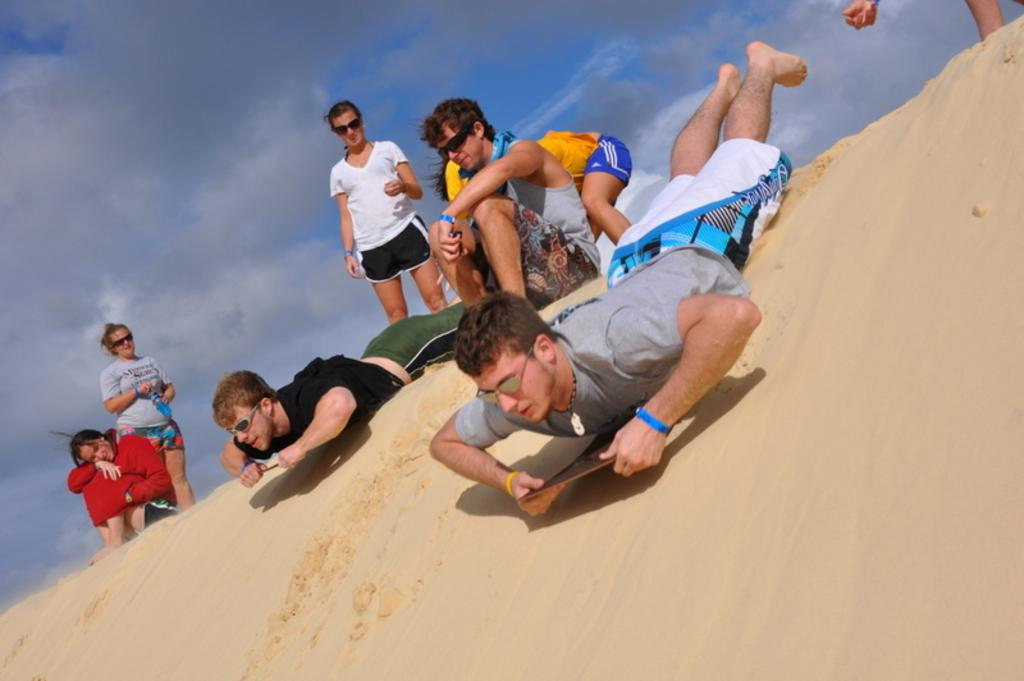How many people are in the image? There are people in the image. What are two people doing in the image? Two people are sliding in the sand. What is visible at the top of the image? The sky is visible at the top of the image. Where is the maid standing in the image? There is no maid present in the image. What direction are the people sliding in the image? The image does not provide enough information to determine the direction in which the people are sliding. 